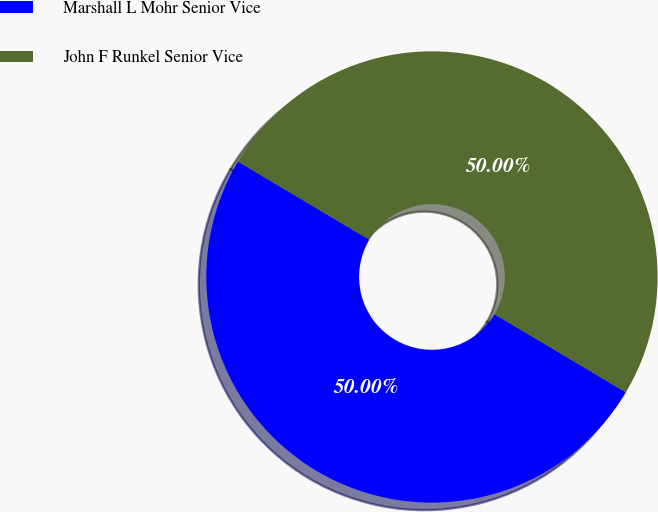<chart> <loc_0><loc_0><loc_500><loc_500><pie_chart><fcel>Marshall L Mohr Senior Vice<fcel>John F Runkel Senior Vice<nl><fcel>50.0%<fcel>50.0%<nl></chart> 